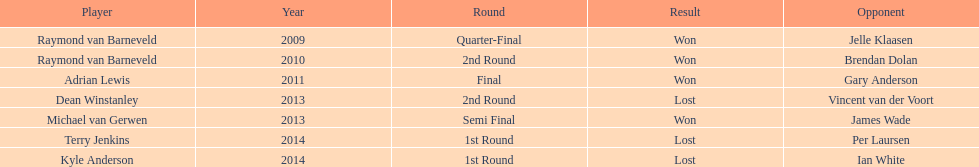Who was the most recent victor against their rival? Michael van Gerwen. 